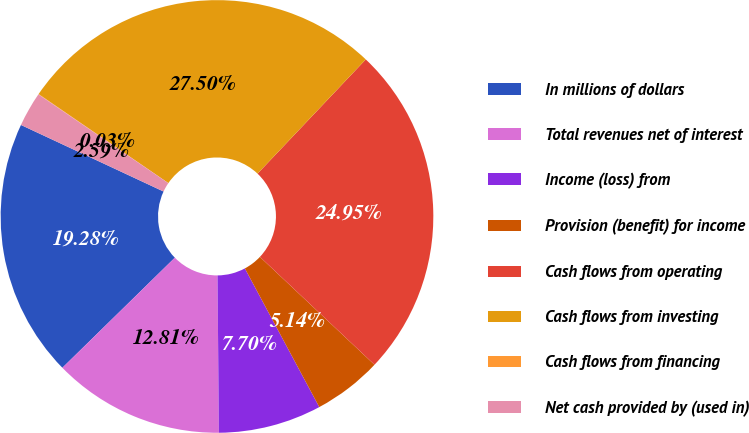Convert chart to OTSL. <chart><loc_0><loc_0><loc_500><loc_500><pie_chart><fcel>In millions of dollars<fcel>Total revenues net of interest<fcel>Income (loss) from<fcel>Provision (benefit) for income<fcel>Cash flows from operating<fcel>Cash flows from investing<fcel>Cash flows from financing<fcel>Net cash provided by (used in)<nl><fcel>19.28%<fcel>12.81%<fcel>7.7%<fcel>5.14%<fcel>24.95%<fcel>27.5%<fcel>0.03%<fcel>2.59%<nl></chart> 